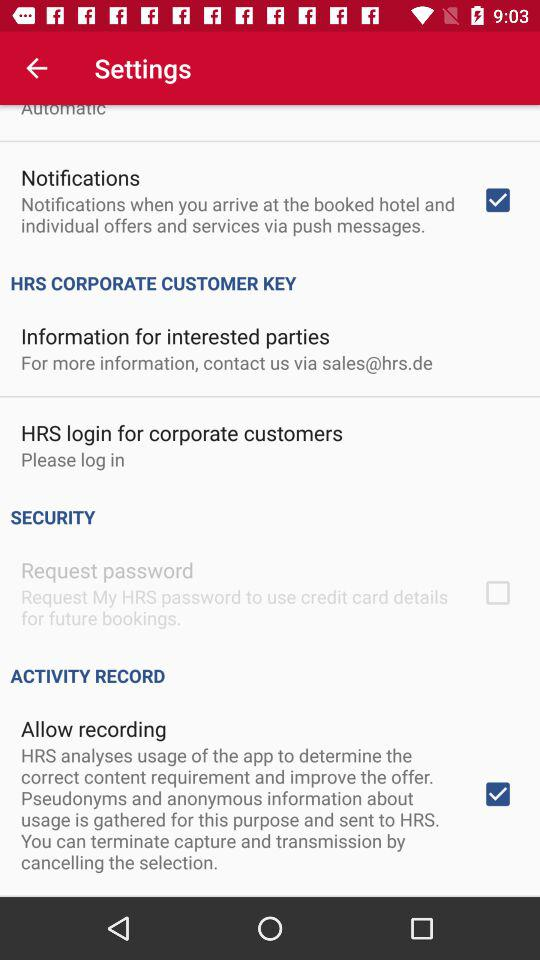What is the email address to contact for more information about the "HRS" corporate customer key? The email address to contact for more information about the "HRS" corporate customer key is sales@hrs.de. 